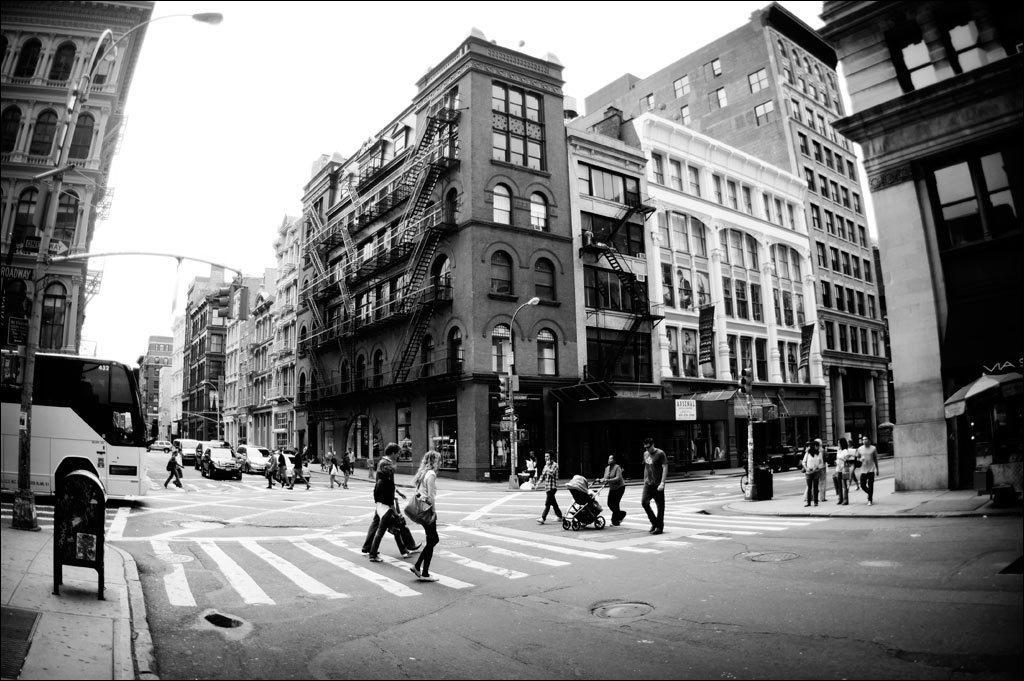How would you summarize this image in a sentence or two? In this picture I can see buildings , in front of building there is a street light pole and person walking on road and crossing the road on zebra cross lines and there are some vehicles and a bus on the left side at the top I can see the sky and a tent on right side and I can see a baby chair in the middle visible on road , and I can see a small pole on left side and top of building there are windows visible. 